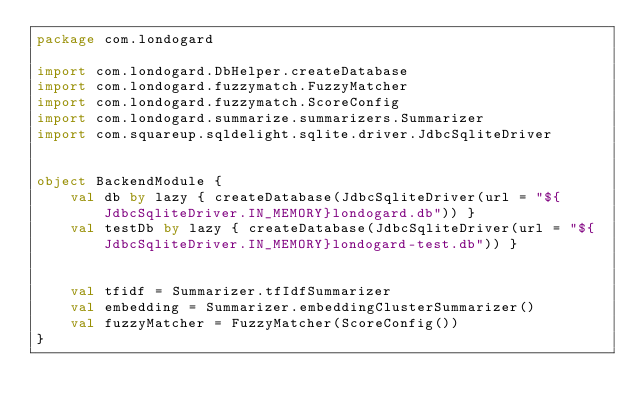<code> <loc_0><loc_0><loc_500><loc_500><_Kotlin_>package com.londogard

import com.londogard.DbHelper.createDatabase
import com.londogard.fuzzymatch.FuzzyMatcher
import com.londogard.fuzzymatch.ScoreConfig
import com.londogard.summarize.summarizers.Summarizer
import com.squareup.sqldelight.sqlite.driver.JdbcSqliteDriver


object BackendModule {
    val db by lazy { createDatabase(JdbcSqliteDriver(url = "${JdbcSqliteDriver.IN_MEMORY}londogard.db")) }
    val testDb by lazy { createDatabase(JdbcSqliteDriver(url = "${JdbcSqliteDriver.IN_MEMORY}londogard-test.db")) }


    val tfidf = Summarizer.tfIdfSummarizer
    val embedding = Summarizer.embeddingClusterSummarizer()
    val fuzzyMatcher = FuzzyMatcher(ScoreConfig())
}</code> 